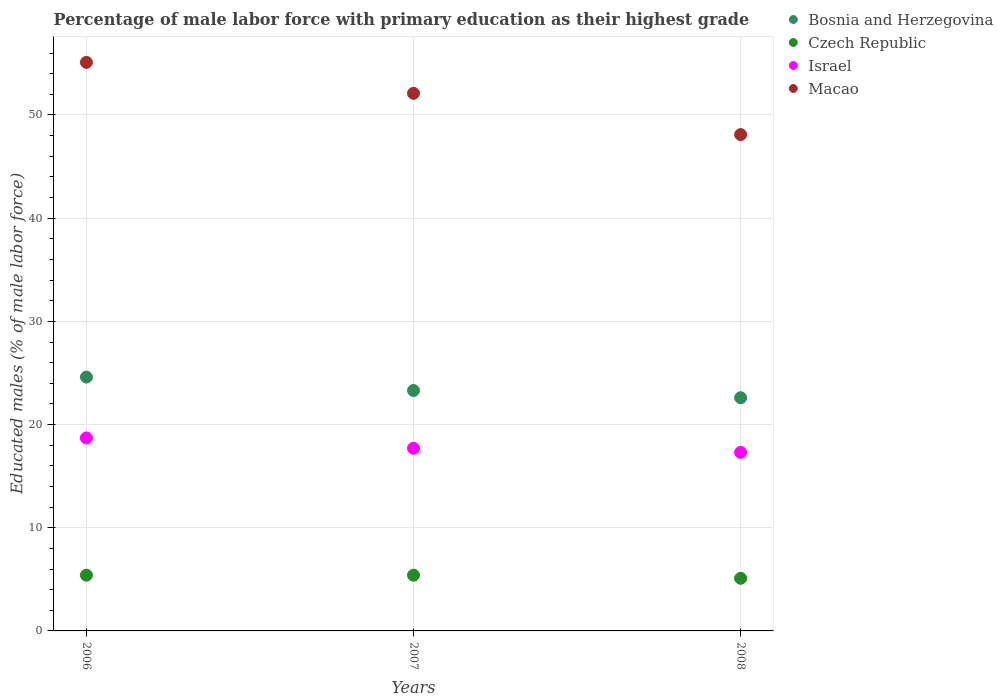How many different coloured dotlines are there?
Give a very brief answer. 4. What is the percentage of male labor force with primary education in Bosnia and Herzegovina in 2006?
Your response must be concise. 24.6. Across all years, what is the maximum percentage of male labor force with primary education in Macao?
Ensure brevity in your answer.  55.1. Across all years, what is the minimum percentage of male labor force with primary education in Macao?
Your answer should be very brief. 48.1. What is the total percentage of male labor force with primary education in Macao in the graph?
Ensure brevity in your answer.  155.3. What is the difference between the percentage of male labor force with primary education in Czech Republic in 2006 and that in 2008?
Your answer should be very brief. 0.3. What is the difference between the percentage of male labor force with primary education in Czech Republic in 2006 and the percentage of male labor force with primary education in Israel in 2008?
Give a very brief answer. -11.9. What is the average percentage of male labor force with primary education in Czech Republic per year?
Your answer should be very brief. 5.3. In the year 2007, what is the difference between the percentage of male labor force with primary education in Czech Republic and percentage of male labor force with primary education in Bosnia and Herzegovina?
Your answer should be compact. -17.9. In how many years, is the percentage of male labor force with primary education in Czech Republic greater than 50 %?
Offer a terse response. 0. What is the ratio of the percentage of male labor force with primary education in Bosnia and Herzegovina in 2006 to that in 2008?
Offer a very short reply. 1.09. What is the difference between the highest and the second highest percentage of male labor force with primary education in Israel?
Your answer should be very brief. 1. What is the difference between the highest and the lowest percentage of male labor force with primary education in Czech Republic?
Provide a succinct answer. 0.3. In how many years, is the percentage of male labor force with primary education in Israel greater than the average percentage of male labor force with primary education in Israel taken over all years?
Give a very brief answer. 1. Is it the case that in every year, the sum of the percentage of male labor force with primary education in Bosnia and Herzegovina and percentage of male labor force with primary education in Israel  is greater than the percentage of male labor force with primary education in Czech Republic?
Your answer should be very brief. Yes. Does the percentage of male labor force with primary education in Macao monotonically increase over the years?
Ensure brevity in your answer.  No. Is the percentage of male labor force with primary education in Bosnia and Herzegovina strictly less than the percentage of male labor force with primary education in Czech Republic over the years?
Provide a short and direct response. No. How many dotlines are there?
Keep it short and to the point. 4. How many years are there in the graph?
Your answer should be compact. 3. What is the difference between two consecutive major ticks on the Y-axis?
Your answer should be compact. 10. Are the values on the major ticks of Y-axis written in scientific E-notation?
Ensure brevity in your answer.  No. What is the title of the graph?
Your response must be concise. Percentage of male labor force with primary education as their highest grade. What is the label or title of the X-axis?
Your response must be concise. Years. What is the label or title of the Y-axis?
Your answer should be compact. Educated males (% of male labor force). What is the Educated males (% of male labor force) of Bosnia and Herzegovina in 2006?
Give a very brief answer. 24.6. What is the Educated males (% of male labor force) of Czech Republic in 2006?
Ensure brevity in your answer.  5.4. What is the Educated males (% of male labor force) of Israel in 2006?
Your answer should be compact. 18.7. What is the Educated males (% of male labor force) in Macao in 2006?
Your answer should be compact. 55.1. What is the Educated males (% of male labor force) of Bosnia and Herzegovina in 2007?
Keep it short and to the point. 23.3. What is the Educated males (% of male labor force) of Czech Republic in 2007?
Keep it short and to the point. 5.4. What is the Educated males (% of male labor force) in Israel in 2007?
Offer a very short reply. 17.7. What is the Educated males (% of male labor force) of Macao in 2007?
Your answer should be very brief. 52.1. What is the Educated males (% of male labor force) of Bosnia and Herzegovina in 2008?
Keep it short and to the point. 22.6. What is the Educated males (% of male labor force) of Czech Republic in 2008?
Ensure brevity in your answer.  5.1. What is the Educated males (% of male labor force) in Israel in 2008?
Provide a succinct answer. 17.3. What is the Educated males (% of male labor force) of Macao in 2008?
Provide a succinct answer. 48.1. Across all years, what is the maximum Educated males (% of male labor force) in Bosnia and Herzegovina?
Provide a short and direct response. 24.6. Across all years, what is the maximum Educated males (% of male labor force) in Czech Republic?
Offer a very short reply. 5.4. Across all years, what is the maximum Educated males (% of male labor force) in Israel?
Offer a very short reply. 18.7. Across all years, what is the maximum Educated males (% of male labor force) in Macao?
Offer a terse response. 55.1. Across all years, what is the minimum Educated males (% of male labor force) of Bosnia and Herzegovina?
Ensure brevity in your answer.  22.6. Across all years, what is the minimum Educated males (% of male labor force) in Czech Republic?
Make the answer very short. 5.1. Across all years, what is the minimum Educated males (% of male labor force) in Israel?
Your response must be concise. 17.3. Across all years, what is the minimum Educated males (% of male labor force) of Macao?
Ensure brevity in your answer.  48.1. What is the total Educated males (% of male labor force) in Bosnia and Herzegovina in the graph?
Provide a short and direct response. 70.5. What is the total Educated males (% of male labor force) in Israel in the graph?
Offer a very short reply. 53.7. What is the total Educated males (% of male labor force) in Macao in the graph?
Offer a terse response. 155.3. What is the difference between the Educated males (% of male labor force) of Israel in 2006 and that in 2007?
Provide a succinct answer. 1. What is the difference between the Educated males (% of male labor force) of Bosnia and Herzegovina in 2006 and that in 2008?
Your response must be concise. 2. What is the difference between the Educated males (% of male labor force) of Czech Republic in 2006 and that in 2008?
Ensure brevity in your answer.  0.3. What is the difference between the Educated males (% of male labor force) of Bosnia and Herzegovina in 2006 and the Educated males (% of male labor force) of Czech Republic in 2007?
Keep it short and to the point. 19.2. What is the difference between the Educated males (% of male labor force) in Bosnia and Herzegovina in 2006 and the Educated males (% of male labor force) in Israel in 2007?
Ensure brevity in your answer.  6.9. What is the difference between the Educated males (% of male labor force) in Bosnia and Herzegovina in 2006 and the Educated males (% of male labor force) in Macao in 2007?
Keep it short and to the point. -27.5. What is the difference between the Educated males (% of male labor force) in Czech Republic in 2006 and the Educated males (% of male labor force) in Macao in 2007?
Provide a short and direct response. -46.7. What is the difference between the Educated males (% of male labor force) of Israel in 2006 and the Educated males (% of male labor force) of Macao in 2007?
Offer a terse response. -33.4. What is the difference between the Educated males (% of male labor force) in Bosnia and Herzegovina in 2006 and the Educated males (% of male labor force) in Macao in 2008?
Your response must be concise. -23.5. What is the difference between the Educated males (% of male labor force) of Czech Republic in 2006 and the Educated males (% of male labor force) of Israel in 2008?
Provide a succinct answer. -11.9. What is the difference between the Educated males (% of male labor force) in Czech Republic in 2006 and the Educated males (% of male labor force) in Macao in 2008?
Your response must be concise. -42.7. What is the difference between the Educated males (% of male labor force) in Israel in 2006 and the Educated males (% of male labor force) in Macao in 2008?
Offer a very short reply. -29.4. What is the difference between the Educated males (% of male labor force) in Bosnia and Herzegovina in 2007 and the Educated males (% of male labor force) in Czech Republic in 2008?
Give a very brief answer. 18.2. What is the difference between the Educated males (% of male labor force) of Bosnia and Herzegovina in 2007 and the Educated males (% of male labor force) of Israel in 2008?
Make the answer very short. 6. What is the difference between the Educated males (% of male labor force) in Bosnia and Herzegovina in 2007 and the Educated males (% of male labor force) in Macao in 2008?
Make the answer very short. -24.8. What is the difference between the Educated males (% of male labor force) of Czech Republic in 2007 and the Educated males (% of male labor force) of Macao in 2008?
Ensure brevity in your answer.  -42.7. What is the difference between the Educated males (% of male labor force) of Israel in 2007 and the Educated males (% of male labor force) of Macao in 2008?
Offer a very short reply. -30.4. What is the average Educated males (% of male labor force) in Bosnia and Herzegovina per year?
Ensure brevity in your answer.  23.5. What is the average Educated males (% of male labor force) in Czech Republic per year?
Make the answer very short. 5.3. What is the average Educated males (% of male labor force) in Macao per year?
Your answer should be compact. 51.77. In the year 2006, what is the difference between the Educated males (% of male labor force) in Bosnia and Herzegovina and Educated males (% of male labor force) in Israel?
Provide a short and direct response. 5.9. In the year 2006, what is the difference between the Educated males (% of male labor force) in Bosnia and Herzegovina and Educated males (% of male labor force) in Macao?
Your response must be concise. -30.5. In the year 2006, what is the difference between the Educated males (% of male labor force) of Czech Republic and Educated males (% of male labor force) of Israel?
Make the answer very short. -13.3. In the year 2006, what is the difference between the Educated males (% of male labor force) of Czech Republic and Educated males (% of male labor force) of Macao?
Give a very brief answer. -49.7. In the year 2006, what is the difference between the Educated males (% of male labor force) of Israel and Educated males (% of male labor force) of Macao?
Make the answer very short. -36.4. In the year 2007, what is the difference between the Educated males (% of male labor force) of Bosnia and Herzegovina and Educated males (% of male labor force) of Macao?
Keep it short and to the point. -28.8. In the year 2007, what is the difference between the Educated males (% of male labor force) of Czech Republic and Educated males (% of male labor force) of Macao?
Ensure brevity in your answer.  -46.7. In the year 2007, what is the difference between the Educated males (% of male labor force) in Israel and Educated males (% of male labor force) in Macao?
Ensure brevity in your answer.  -34.4. In the year 2008, what is the difference between the Educated males (% of male labor force) in Bosnia and Herzegovina and Educated males (% of male labor force) in Macao?
Offer a very short reply. -25.5. In the year 2008, what is the difference between the Educated males (% of male labor force) of Czech Republic and Educated males (% of male labor force) of Israel?
Give a very brief answer. -12.2. In the year 2008, what is the difference between the Educated males (% of male labor force) of Czech Republic and Educated males (% of male labor force) of Macao?
Provide a short and direct response. -43. In the year 2008, what is the difference between the Educated males (% of male labor force) of Israel and Educated males (% of male labor force) of Macao?
Make the answer very short. -30.8. What is the ratio of the Educated males (% of male labor force) of Bosnia and Herzegovina in 2006 to that in 2007?
Ensure brevity in your answer.  1.06. What is the ratio of the Educated males (% of male labor force) in Israel in 2006 to that in 2007?
Provide a succinct answer. 1.06. What is the ratio of the Educated males (% of male labor force) of Macao in 2006 to that in 2007?
Offer a terse response. 1.06. What is the ratio of the Educated males (% of male labor force) of Bosnia and Herzegovina in 2006 to that in 2008?
Your answer should be compact. 1.09. What is the ratio of the Educated males (% of male labor force) in Czech Republic in 2006 to that in 2008?
Provide a succinct answer. 1.06. What is the ratio of the Educated males (% of male labor force) in Israel in 2006 to that in 2008?
Ensure brevity in your answer.  1.08. What is the ratio of the Educated males (% of male labor force) of Macao in 2006 to that in 2008?
Make the answer very short. 1.15. What is the ratio of the Educated males (% of male labor force) in Bosnia and Herzegovina in 2007 to that in 2008?
Keep it short and to the point. 1.03. What is the ratio of the Educated males (% of male labor force) of Czech Republic in 2007 to that in 2008?
Provide a succinct answer. 1.06. What is the ratio of the Educated males (% of male labor force) of Israel in 2007 to that in 2008?
Your answer should be very brief. 1.02. What is the ratio of the Educated males (% of male labor force) in Macao in 2007 to that in 2008?
Offer a terse response. 1.08. What is the difference between the highest and the second highest Educated males (% of male labor force) in Czech Republic?
Keep it short and to the point. 0. What is the difference between the highest and the second highest Educated males (% of male labor force) in Israel?
Keep it short and to the point. 1. What is the difference between the highest and the lowest Educated males (% of male labor force) in Czech Republic?
Offer a very short reply. 0.3. What is the difference between the highest and the lowest Educated males (% of male labor force) in Israel?
Provide a succinct answer. 1.4. 